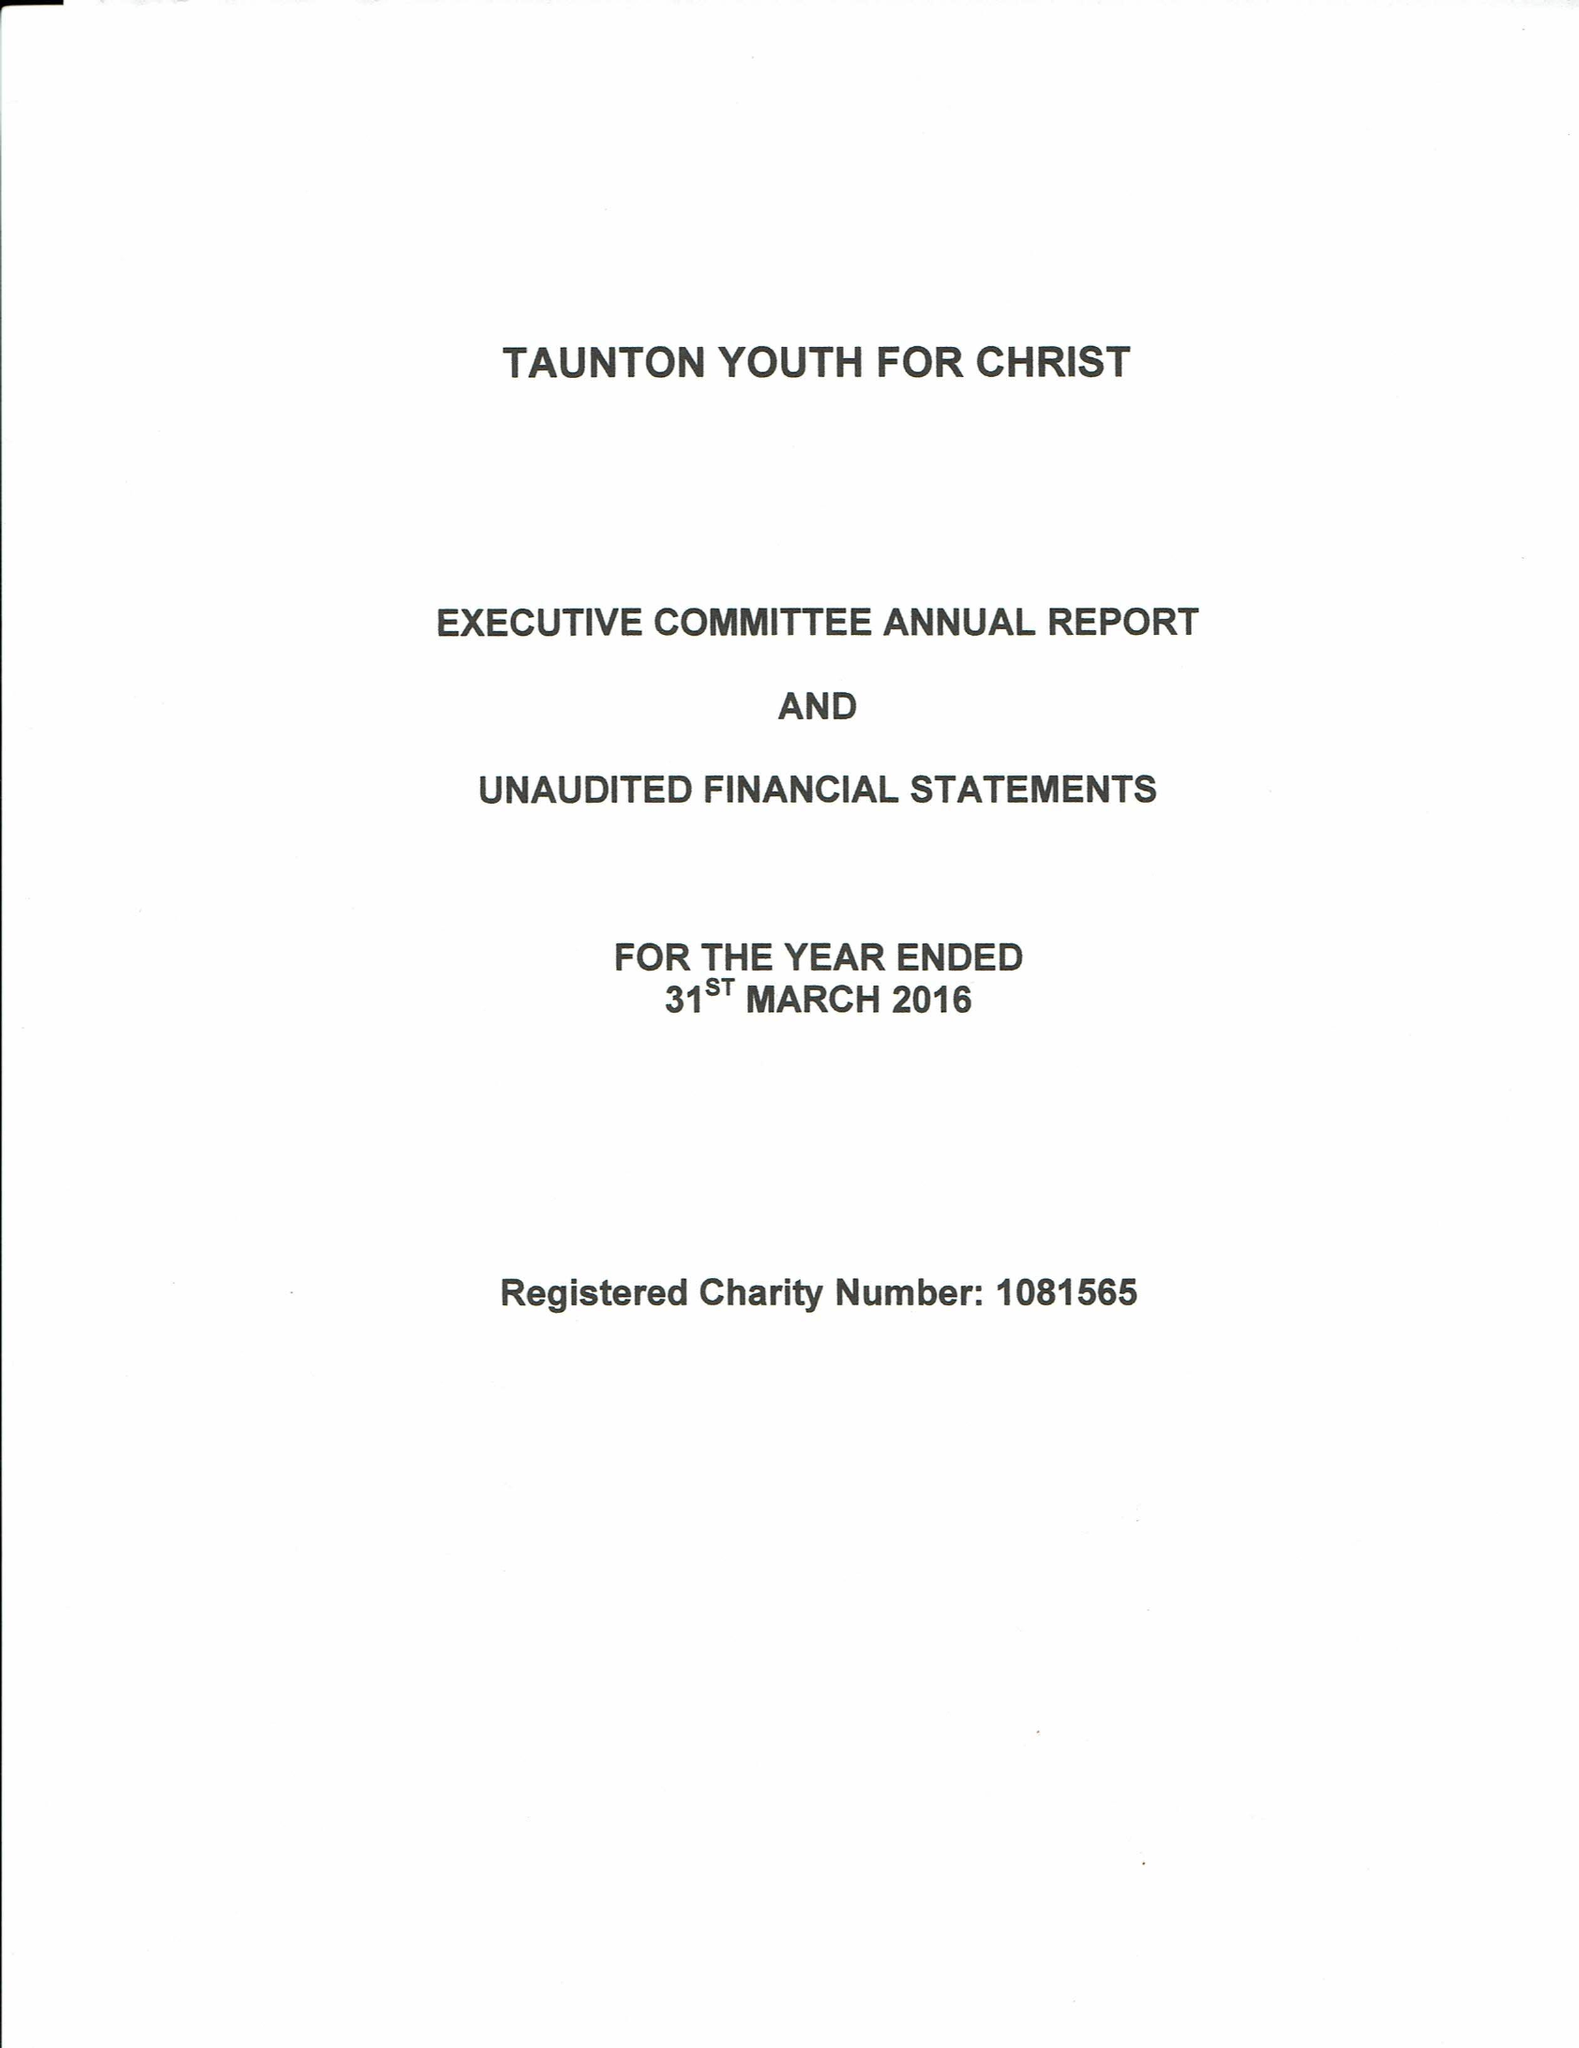What is the value for the address__postcode?
Answer the question using a single word or phrase. TA1 3JU 